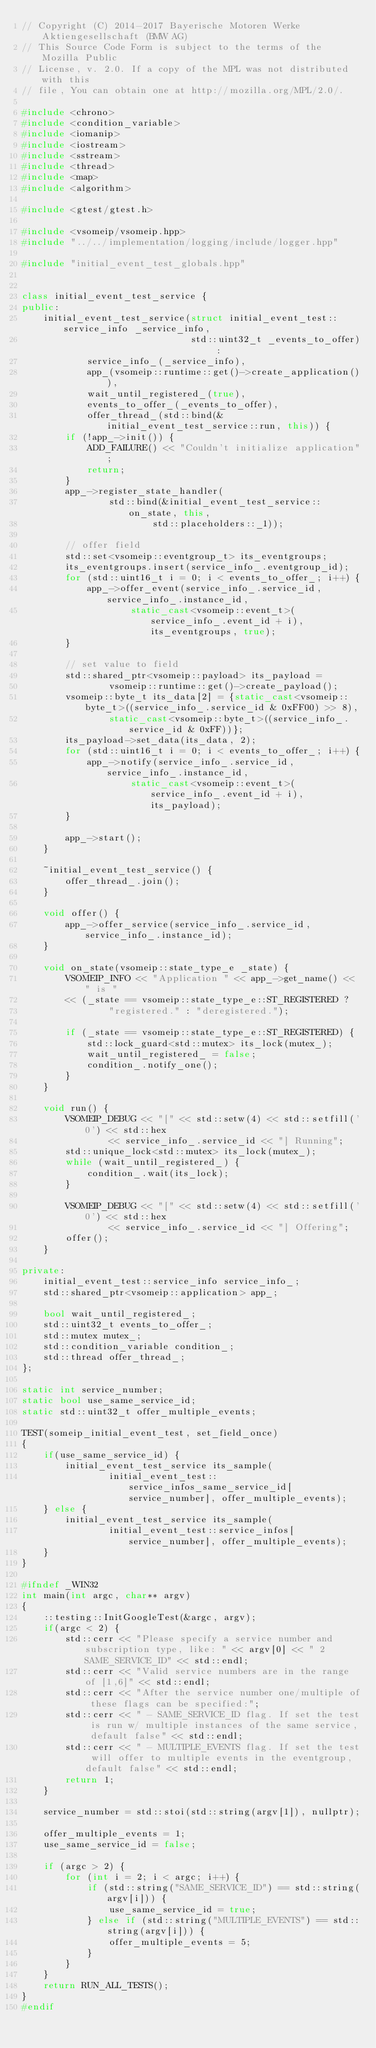<code> <loc_0><loc_0><loc_500><loc_500><_C++_>// Copyright (C) 2014-2017 Bayerische Motoren Werke Aktiengesellschaft (BMW AG)
// This Source Code Form is subject to the terms of the Mozilla Public
// License, v. 2.0. If a copy of the MPL was not distributed with this
// file, You can obtain one at http://mozilla.org/MPL/2.0/.

#include <chrono>
#include <condition_variable>
#include <iomanip>
#include <iostream>
#include <sstream>
#include <thread>
#include <map>
#include <algorithm>

#include <gtest/gtest.h>

#include <vsomeip/vsomeip.hpp>
#include "../../implementation/logging/include/logger.hpp"

#include "initial_event_test_globals.hpp"


class initial_event_test_service {
public:
    initial_event_test_service(struct initial_event_test::service_info _service_info,
                               std::uint32_t _events_to_offer) :
            service_info_(_service_info),
            app_(vsomeip::runtime::get()->create_application()),
            wait_until_registered_(true),
            events_to_offer_(_events_to_offer),
            offer_thread_(std::bind(&initial_event_test_service::run, this)) {
        if (!app_->init()) {
            ADD_FAILURE() << "Couldn't initialize application";
            return;
        }
        app_->register_state_handler(
                std::bind(&initial_event_test_service::on_state, this,
                        std::placeholders::_1));

        // offer field
        std::set<vsomeip::eventgroup_t> its_eventgroups;
        its_eventgroups.insert(service_info_.eventgroup_id);
        for (std::uint16_t i = 0; i < events_to_offer_; i++) {
            app_->offer_event(service_info_.service_id, service_info_.instance_id,
                    static_cast<vsomeip::event_t>(service_info_.event_id + i), its_eventgroups, true);
        }

        // set value to field
        std::shared_ptr<vsomeip::payload> its_payload =
                vsomeip::runtime::get()->create_payload();
        vsomeip::byte_t its_data[2] = {static_cast<vsomeip::byte_t>((service_info_.service_id & 0xFF00) >> 8),
                static_cast<vsomeip::byte_t>((service_info_.service_id & 0xFF))};
        its_payload->set_data(its_data, 2);
        for (std::uint16_t i = 0; i < events_to_offer_; i++) {
            app_->notify(service_info_.service_id, service_info_.instance_id,
                    static_cast<vsomeip::event_t>(service_info_.event_id + i), its_payload);
        }

        app_->start();
    }

    ~initial_event_test_service() {
        offer_thread_.join();
    }

    void offer() {
        app_->offer_service(service_info_.service_id, service_info_.instance_id);
    }

    void on_state(vsomeip::state_type_e _state) {
        VSOMEIP_INFO << "Application " << app_->get_name() << " is "
        << (_state == vsomeip::state_type_e::ST_REGISTERED ?
                "registered." : "deregistered.");

        if (_state == vsomeip::state_type_e::ST_REGISTERED) {
            std::lock_guard<std::mutex> its_lock(mutex_);
            wait_until_registered_ = false;
            condition_.notify_one();
        }
    }

    void run() {
        VSOMEIP_DEBUG << "[" << std::setw(4) << std::setfill('0') << std::hex
                << service_info_.service_id << "] Running";
        std::unique_lock<std::mutex> its_lock(mutex_);
        while (wait_until_registered_) {
            condition_.wait(its_lock);
        }

        VSOMEIP_DEBUG << "[" << std::setw(4) << std::setfill('0') << std::hex
                << service_info_.service_id << "] Offering";
        offer();
    }

private:
    initial_event_test::service_info service_info_;
    std::shared_ptr<vsomeip::application> app_;

    bool wait_until_registered_;
    std::uint32_t events_to_offer_;
    std::mutex mutex_;
    std::condition_variable condition_;
    std::thread offer_thread_;
};

static int service_number;
static bool use_same_service_id;
static std::uint32_t offer_multiple_events;

TEST(someip_initial_event_test, set_field_once)
{
    if(use_same_service_id) {
        initial_event_test_service its_sample(
                initial_event_test::service_infos_same_service_id[service_number], offer_multiple_events);
    } else {
        initial_event_test_service its_sample(
                initial_event_test::service_infos[service_number], offer_multiple_events);
    }
}

#ifndef _WIN32
int main(int argc, char** argv)
{
    ::testing::InitGoogleTest(&argc, argv);
    if(argc < 2) {
        std::cerr << "Please specify a service number and subscription type, like: " << argv[0] << " 2 SAME_SERVICE_ID" << std::endl;
        std::cerr << "Valid service numbers are in the range of [1,6]" << std::endl;
        std::cerr << "After the service number one/multiple of these flags can be specified:";
        std::cerr << " - SAME_SERVICE_ID flag. If set the test is run w/ multiple instances of the same service, default false" << std::endl;
        std::cerr << " - MULTIPLE_EVENTS flag. If set the test will offer to multiple events in the eventgroup, default false" << std::endl;
        return 1;
    }

    service_number = std::stoi(std::string(argv[1]), nullptr);

    offer_multiple_events = 1;
    use_same_service_id = false;

    if (argc > 2) {
        for (int i = 2; i < argc; i++) {
            if (std::string("SAME_SERVICE_ID") == std::string(argv[i])) {
                use_same_service_id = true;
            } else if (std::string("MULTIPLE_EVENTS") == std::string(argv[i])) {
                offer_multiple_events = 5;
            }
        }
    }
    return RUN_ALL_TESTS();
}
#endif
</code> 